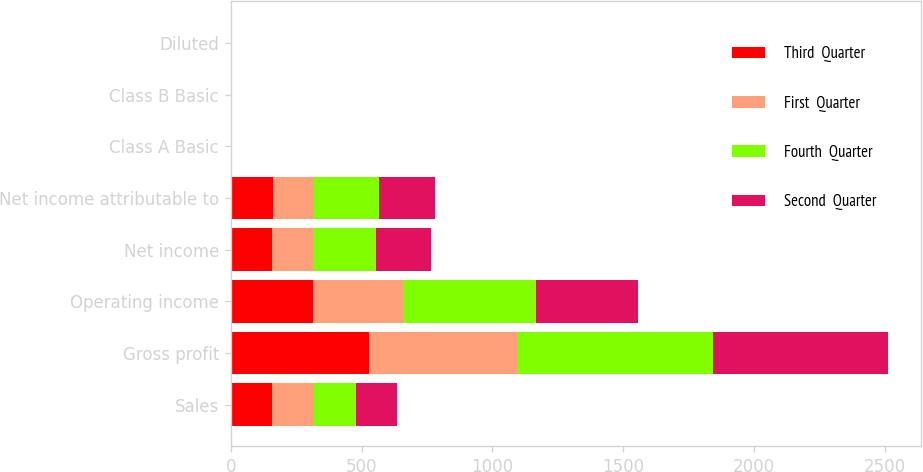Convert chart to OTSL. <chart><loc_0><loc_0><loc_500><loc_500><stacked_bar_chart><ecel><fcel>Sales<fcel>Gross profit<fcel>Operating income<fcel>Net income<fcel>Net income attributable to<fcel>Class A Basic<fcel>Class B Basic<fcel>Diluted<nl><fcel>Third  Quarter<fcel>159<fcel>529<fcel>314<fcel>159<fcel>160<fcel>0.44<fcel>0.39<fcel>0.42<nl><fcel>First  Quarter<fcel>159<fcel>564<fcel>344<fcel>156<fcel>159<fcel>0.43<fcel>0.39<fcel>0.42<nl><fcel>Fourth  Quarter<fcel>159<fcel>752<fcel>507<fcel>242<fcel>248<fcel>0.68<fcel>0.61<fcel>0.65<nl><fcel>Second  Quarter<fcel>159<fcel>669<fcel>391<fcel>208<fcel>213<fcel>0.58<fcel>0.52<fcel>0.57<nl></chart> 